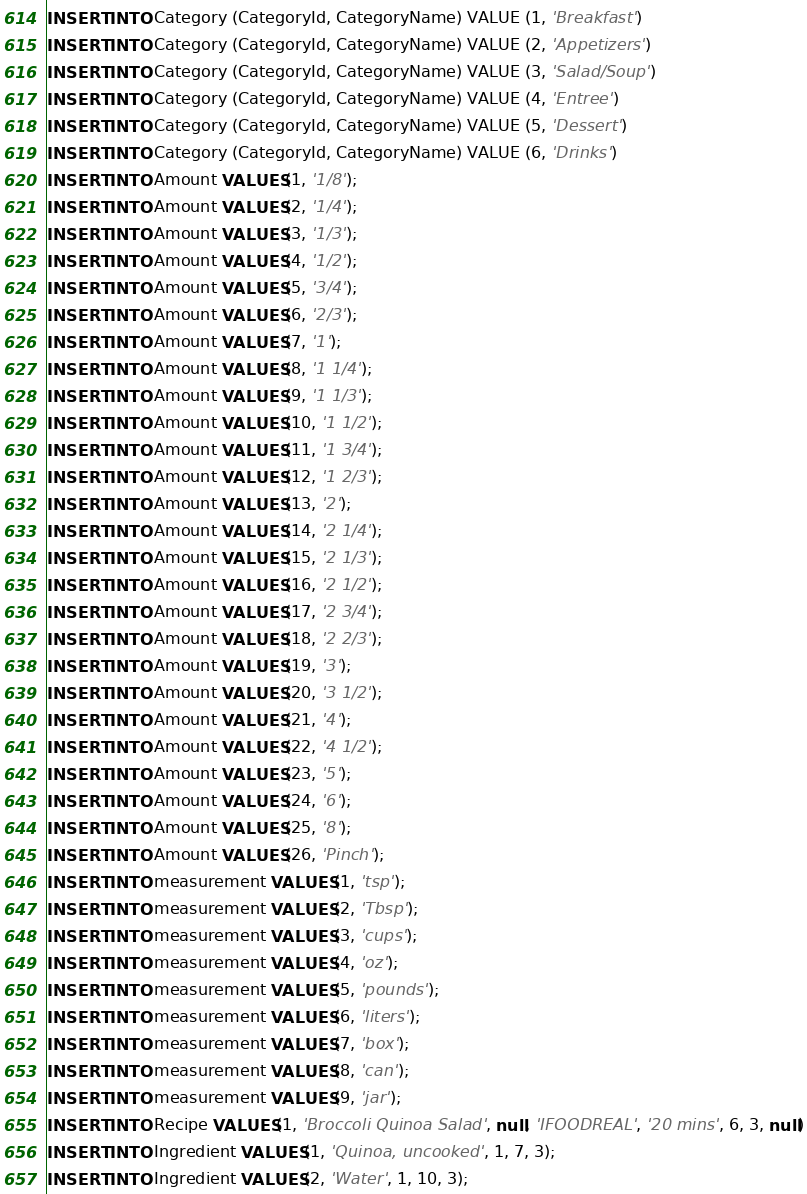Convert code to text. <code><loc_0><loc_0><loc_500><loc_500><_SQL_>INSERT INTO Category (CategoryId, CategoryName) VALUE (1, 'Breakfast')
INSERT INTO Category (CategoryId, CategoryName) VALUE (2, 'Appetizers')
INSERT INTO Category (CategoryId, CategoryName) VALUE (3, 'Salad/Soup')
INSERT INTO Category (CategoryId, CategoryName) VALUE (4, 'Entree')
INSERT INTO Category (CategoryId, CategoryName) VALUE (5, 'Dessert')
INSERT INTO Category (CategoryId, CategoryName) VALUE (6, 'Drinks')
INSERT INTO Amount VALUES(1, '1/8');
INSERT INTO Amount VALUES(2, '1/4');
INSERT INTO Amount VALUES(3, '1/3');
INSERT INTO Amount VALUES(4, '1/2');
INSERT INTO Amount VALUES(5, '3/4');
INSERT INTO Amount VALUES(6, '2/3');
INSERT INTO Amount VALUES(7, '1');
INSERT INTO Amount VALUES(8, '1 1/4');
INSERT INTO Amount VALUES(9, '1 1/3');
INSERT INTO Amount VALUES(10, '1 1/2');
INSERT INTO Amount VALUES(11, '1 3/4');
INSERT INTO Amount VALUES(12, '1 2/3');
INSERT INTO Amount VALUES(13, '2');
INSERT INTO Amount VALUES(14, '2 1/4');
INSERT INTO Amount VALUES(15, '2 1/3');
INSERT INTO Amount VALUES(16, '2 1/2');
INSERT INTO Amount VALUES(17, '2 3/4');
INSERT INTO Amount VALUES(18, '2 2/3');
INSERT INTO Amount VALUES(19, '3');
INSERT INTO Amount VALUES(20, '3 1/2');
INSERT INTO Amount VALUES(21, '4');
INSERT INTO Amount VALUES(22, '4 1/2');
INSERT INTO Amount VALUES(23, '5');
INSERT INTO Amount VALUES(24, '6');
INSERT INTO Amount VALUES(25, '8');
INSERT INTO Amount VALUES(26, 'Pinch');
INSERT INTO measurement VALUES(1, 'tsp');
INSERT INTO measurement VALUES(2, 'Tbsp');
INSERT INTO measurement VALUES(3, 'cups');
INSERT INTO measurement VALUES(4, 'oz');
INSERT INTO measurement VALUES(5, 'pounds');
INSERT INTO measurement VALUES(6, 'liters');
INSERT INTO measurement VALUES(7, 'box');
INSERT INTO measurement VALUES(8, 'can');
INSERT INTO measurement VALUES(9, 'jar');
INSERT INTO Recipe VALUES(1, 'Broccoli Quinoa Salad', null, 'IFOODREAL', '20 mins', 6, 3, null)
INSERT INTO Ingredient VALUES(1, 'Quinoa, uncooked', 1, 7, 3);
INSERT INTO Ingredient VALUES(2, 'Water', 1, 10, 3);</code> 